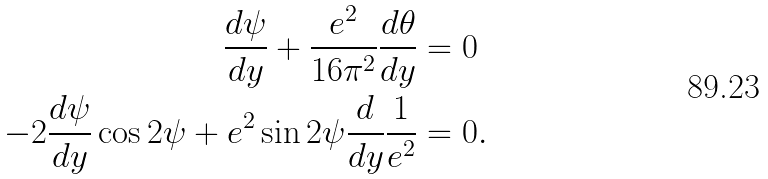<formula> <loc_0><loc_0><loc_500><loc_500>\frac { d \psi } { d y } + \frac { e ^ { 2 } } { 1 6 \pi ^ { 2 } } \frac { d \theta } { d y } & = 0 \\ - 2 \frac { d \psi } { d y } \cos 2 \psi + e ^ { 2 } \sin 2 \psi \frac { d } { d y } \frac { 1 } { e ^ { 2 } } & = 0 .</formula> 